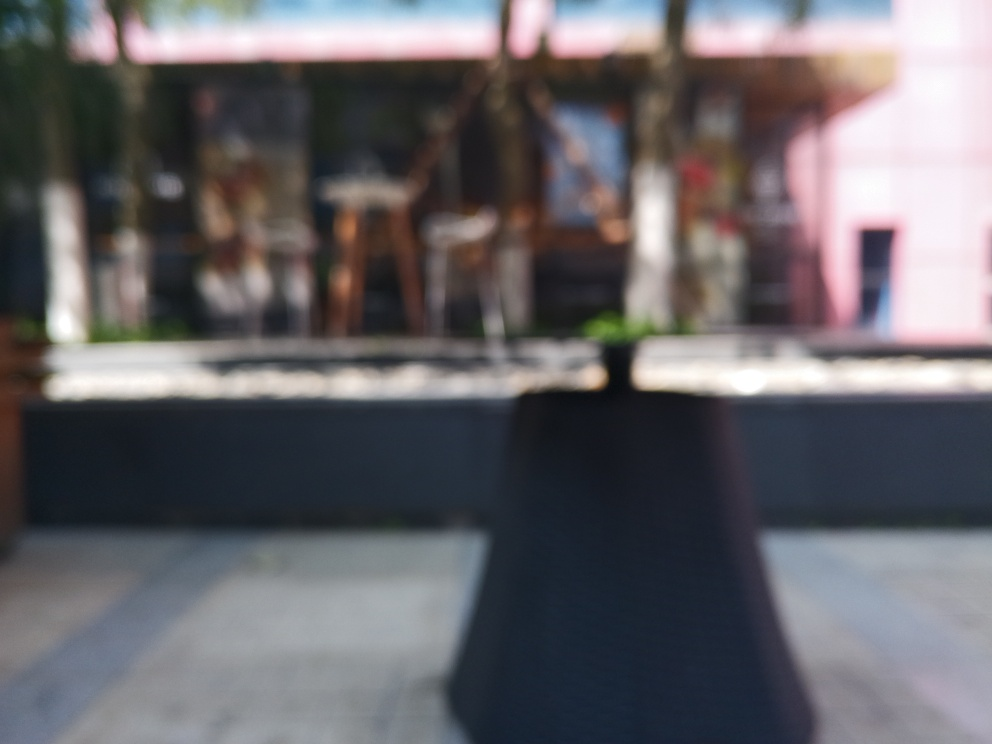Can you describe any shapes or colors that can be made out despite the blurriness? Although the image is quite blurred, we can still observe some basic forms and hues. There appears to be a rectangular structure that might be a table in the foreground, and behind it, possibly chairs or stools. In terms of color, there are various shades of brown and gray, as well as a hint of greenery, which suggests plants may be present. 